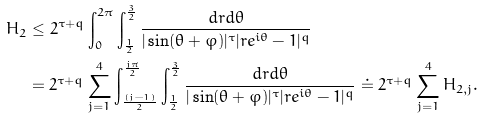Convert formula to latex. <formula><loc_0><loc_0><loc_500><loc_500>H _ { 2 } & \leq 2 ^ { \tau + q } \int _ { 0 } ^ { 2 \pi } \int _ { \frac { 1 } { 2 } } ^ { \frac { 3 } { 2 } } \frac { d r d \theta } { | \sin ( \theta + \varphi ) | ^ { \tau } | r e ^ { i \theta } - 1 | ^ { q } } \\ & = 2 ^ { \tau + q } \sum _ { j = 1 } ^ { 4 } \int _ { \frac { ( j - 1 ) } { 2 } } ^ { \frac { j \pi } { 2 } } \int _ { \frac { 1 } { 2 } } ^ { \frac { 3 } { 2 } } \frac { d r d \theta } { | \sin ( \theta + \varphi ) | ^ { \tau } | r e ^ { i \theta } - 1 | ^ { q } } \doteq 2 ^ { \tau + q } \sum _ { j = 1 } ^ { 4 } H _ { 2 , j } .</formula> 